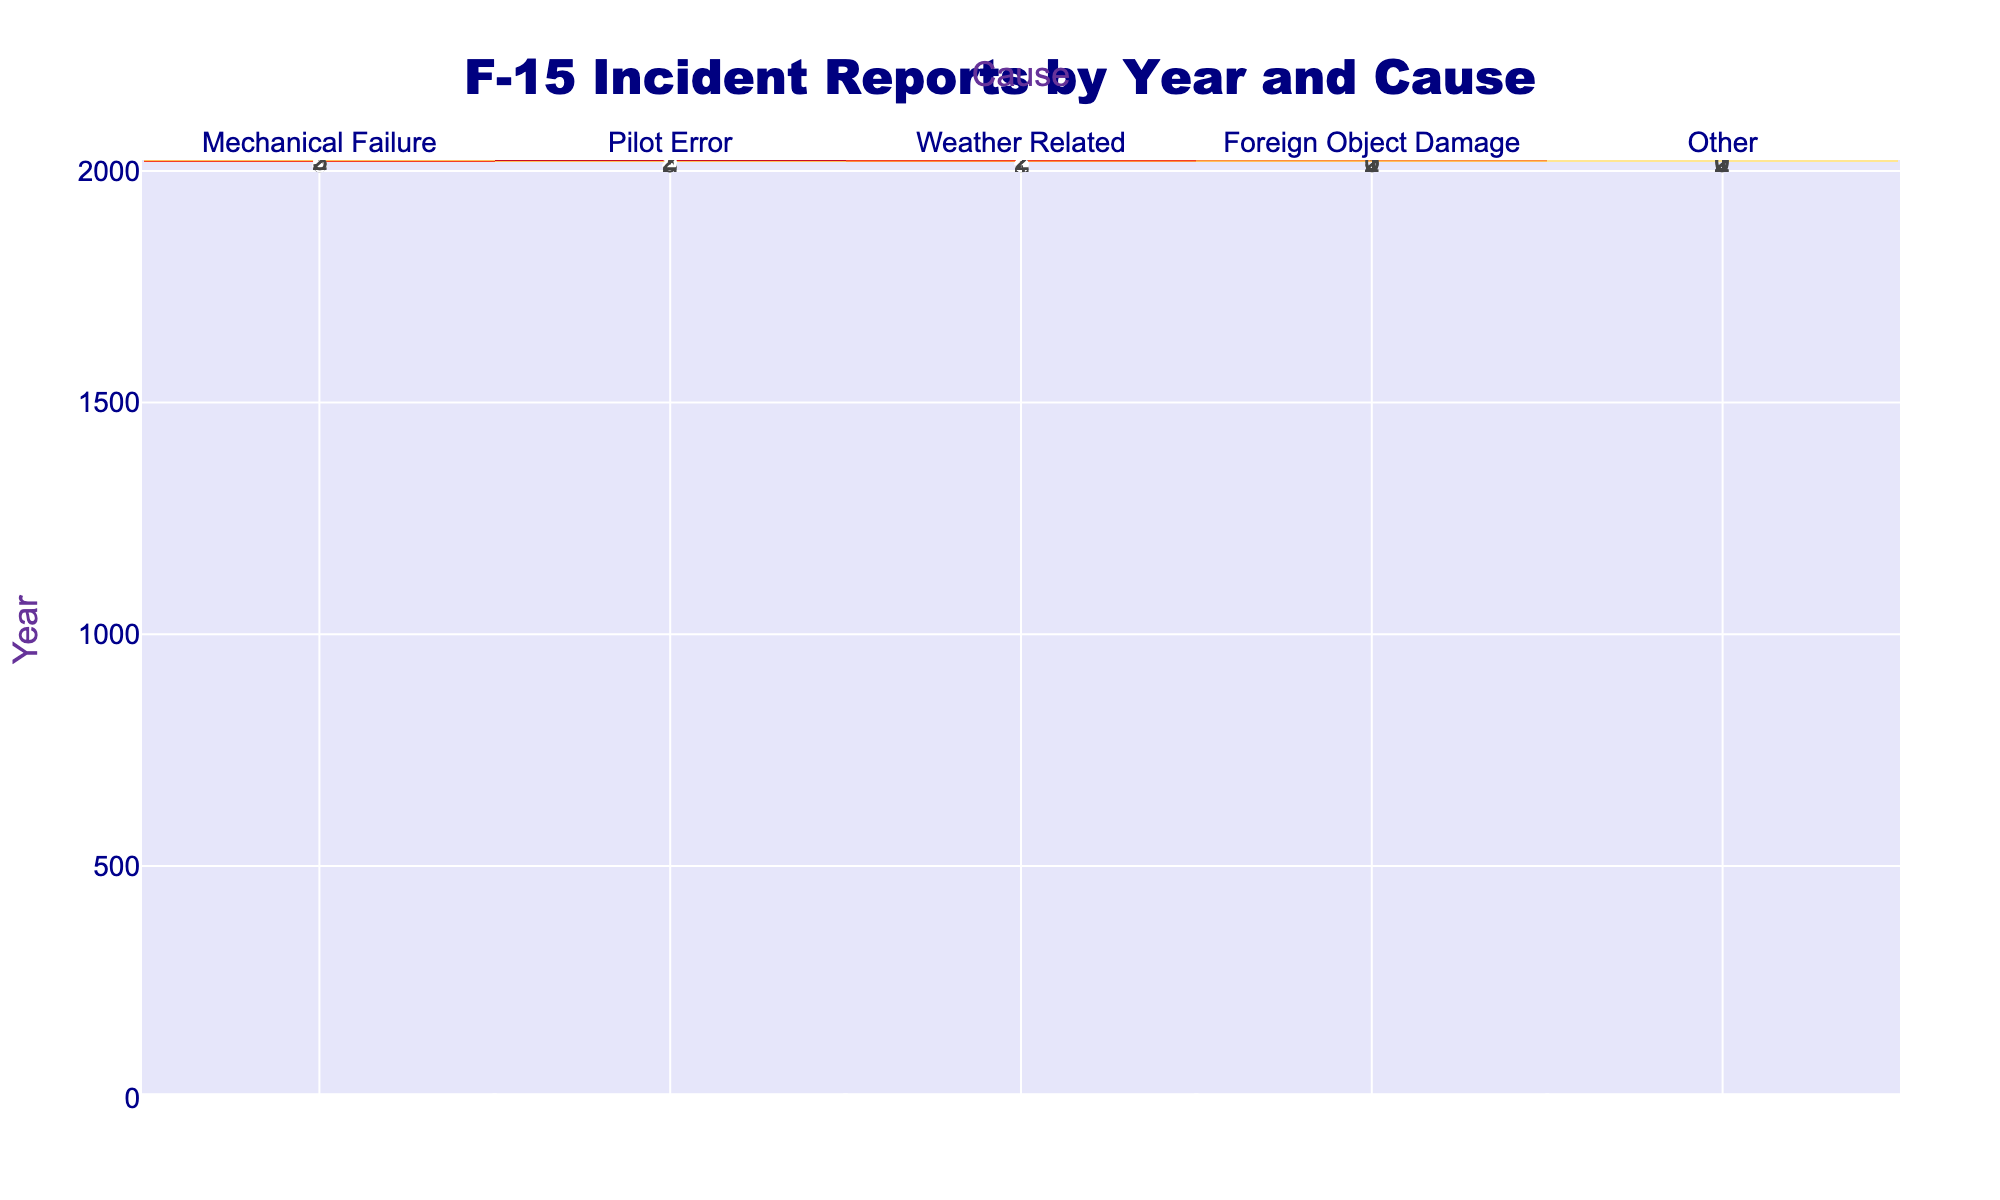What is the total number of incident reports in 2020? To find the total for 2020, we add up the counts for each cause: Mechanical Failure (3) + Pilot Error (4) + Weather Related (5) + Foreign Object Damage (1) + Other (0) = 3 + 4 + 5 + 1 + 0 = 13
Answer: 13 In which year did Pilot Error incidents peak? By examining the table, we look at the values under the Pilot Error column for each year. The highest count is 5 in 2022, indicating that Pilot Error incidents peaked in that year.
Answer: 2022 What is the difference in Mechanical Failure incidents between 2018 and 2021? We find the count of Mechanical Failure incidents for both years: 2018 (5) and 2021 (6). The difference is 6 - 5 = 1, indicating there was one more incident in 2021 compared to 2018.
Answer: 1 Is Foreign Object Damage higher in 2019 than in 2020? In 2019, the count for Foreign Object Damage is 2, while in 2020 it is 1. Since 2 is greater than 1, we conclude that Foreign Object Damage was indeed higher in 2019 than in 2020.
Answer: Yes What is the average number of incidents due to Weather Related causes from 2018 to 2023? We calculate the sum of Weather Related incidents over the six years: 2 + 3 + 5 + 1 + 4 + 2 = 17. To find the average, we divide by the number of years (6): 17 / 6 = 2.83. Therefore, the average number of Weather Related incidents per year is approximately 2.83.
Answer: Approximately 2.83 Which cause of incidents saw the highest count in 2021? By inspecting the 2021 row, we see the counts for each cause: Mechanical Failure (6), Pilot Error (3), Weather Related (1), Foreign Object Damage (0), and Other (2). The highest count is for Mechanical Failure with 6 incidents.
Answer: Mechanical Failure How many total incidents were recorded for "Other" causes over the years? We total the counts for the Other column across all years: 2 + 1 + 0 + 2 + 1 + 0 = 6. This indicates that for Other causes, there were 6 incidents recorded from 2018 to 2023.
Answer: 6 Which year had the least number of overall incidents? We calculate the total number of incidents for each year: 2018 (12), 2019 (12), 2020 (13), 2021 (12), 2022 (15), and 2023 (8). The lowest total is in 2023 with 8 incidents, making it the year with the least overall incidents.
Answer: 2023 